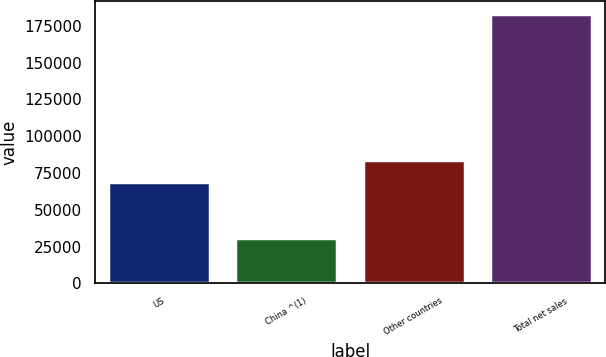Convert chart. <chart><loc_0><loc_0><loc_500><loc_500><bar_chart><fcel>US<fcel>China ^(1)<fcel>Other countries<fcel>Total net sales<nl><fcel>68909<fcel>30638<fcel>84124.7<fcel>182795<nl></chart> 